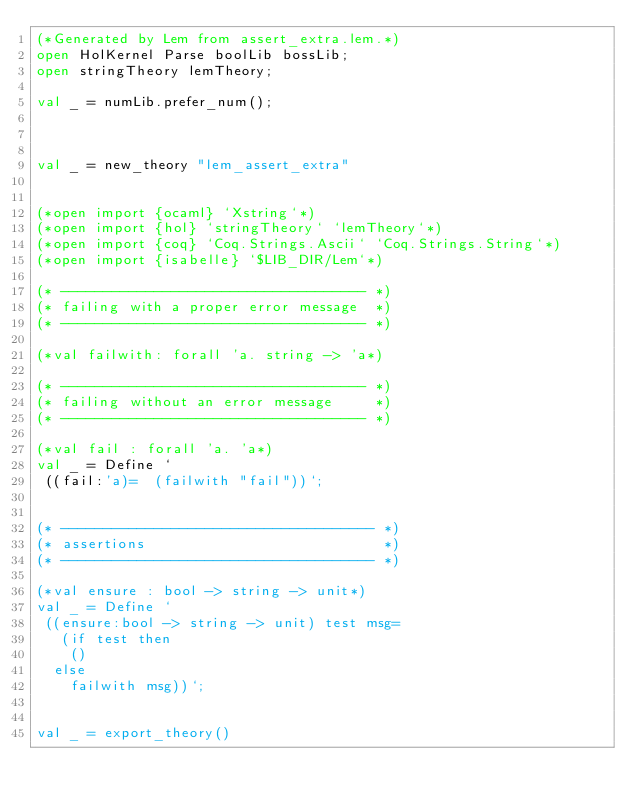Convert code to text. <code><loc_0><loc_0><loc_500><loc_500><_SML_>(*Generated by Lem from assert_extra.lem.*)
open HolKernel Parse boolLib bossLib;
open stringTheory lemTheory;

val _ = numLib.prefer_num();



val _ = new_theory "lem_assert_extra"


(*open import {ocaml} `Xstring`*)
(*open import {hol} `stringTheory` `lemTheory`*)
(*open import {coq} `Coq.Strings.Ascii` `Coq.Strings.String`*)
(*open import {isabelle} `$LIB_DIR/Lem`*)

(* ------------------------------------ *)
(* failing with a proper error message  *)
(* ------------------------------------ *)

(*val failwith: forall 'a. string -> 'a*)

(* ------------------------------------ *)
(* failing without an error message     *)
(* ------------------------------------ *)

(*val fail : forall 'a. 'a*)
val _ = Define `
 ((fail:'a)=  (failwith "fail"))`;


(* ------------------------------------- *)
(* assertions                            *)
(* ------------------------------------- *)

(*val ensure : bool -> string -> unit*)
val _ = Define `
 ((ensure:bool -> string -> unit) test msg=
   (if test then
    () 
  else
    failwith msg))`;


val _ = export_theory()

</code> 